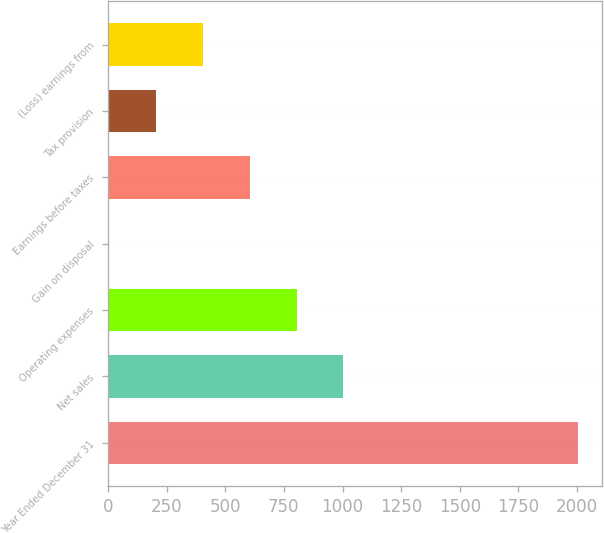Convert chart to OTSL. <chart><loc_0><loc_0><loc_500><loc_500><bar_chart><fcel>Year Ended December 31<fcel>Net sales<fcel>Operating expenses<fcel>Gain on disposal<fcel>Earnings before taxes<fcel>Tax provision<fcel>(Loss) earnings from<nl><fcel>2004<fcel>1004<fcel>804<fcel>4<fcel>604<fcel>204<fcel>404<nl></chart> 